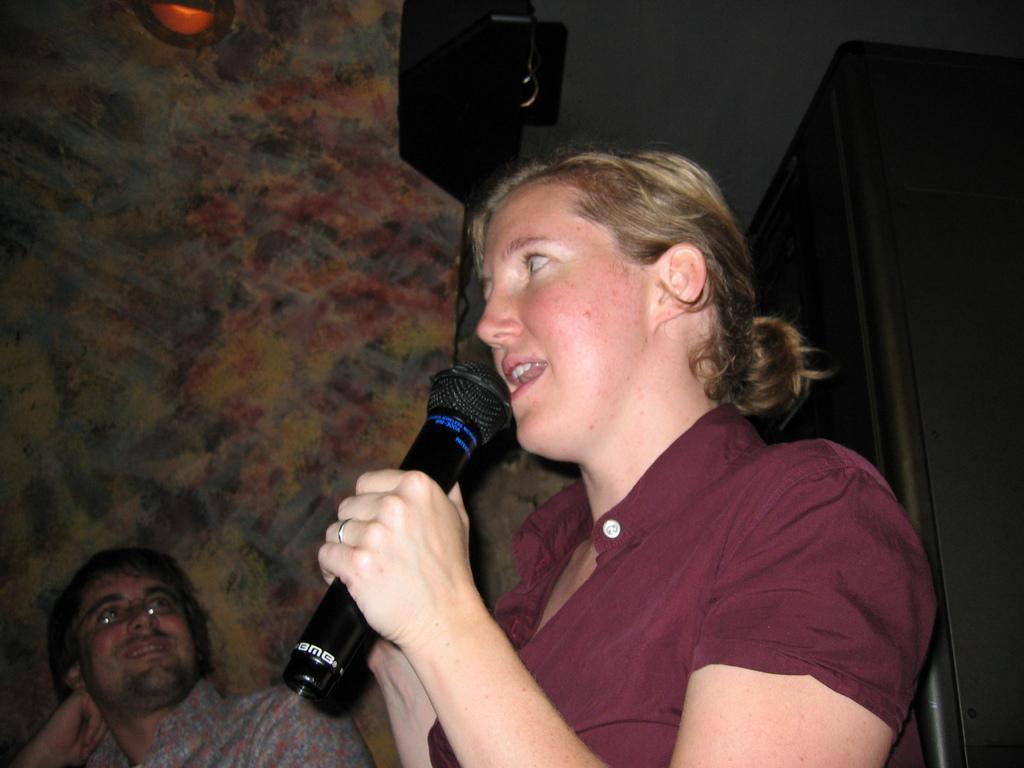Can you describe this image briefly? In this image In the middle there is a woman she wears brown dress she is singing her hair is short. On the left there is a man he is smiling. In the background there is a light and wall. 